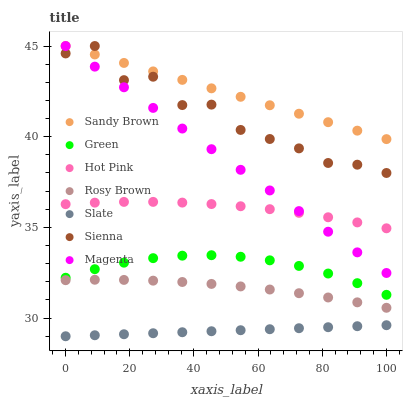Does Slate have the minimum area under the curve?
Answer yes or no. Yes. Does Sandy Brown have the maximum area under the curve?
Answer yes or no. Yes. Does Rosy Brown have the minimum area under the curve?
Answer yes or no. No. Does Rosy Brown have the maximum area under the curve?
Answer yes or no. No. Is Slate the smoothest?
Answer yes or no. Yes. Is Sienna the roughest?
Answer yes or no. Yes. Is Rosy Brown the smoothest?
Answer yes or no. No. Is Rosy Brown the roughest?
Answer yes or no. No. Does Slate have the lowest value?
Answer yes or no. Yes. Does Rosy Brown have the lowest value?
Answer yes or no. No. Does Sandy Brown have the highest value?
Answer yes or no. Yes. Does Rosy Brown have the highest value?
Answer yes or no. No. Is Rosy Brown less than Green?
Answer yes or no. Yes. Is Magenta greater than Green?
Answer yes or no. Yes. Does Sandy Brown intersect Magenta?
Answer yes or no. Yes. Is Sandy Brown less than Magenta?
Answer yes or no. No. Is Sandy Brown greater than Magenta?
Answer yes or no. No. Does Rosy Brown intersect Green?
Answer yes or no. No. 